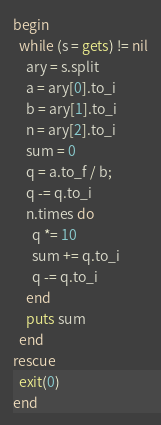Convert code to text. <code><loc_0><loc_0><loc_500><loc_500><_Ruby_>begin
  while (s = gets) != nil
    ary = s.split
    a = ary[0].to_i
    b = ary[1].to_i
    n = ary[2].to_i
    sum = 0
    q = a.to_f / b;
    q -= q.to_i
    n.times do
      q *= 10
      sum += q.to_i
      q -= q.to_i
    end
    puts sum
  end
rescue
  exit(0)
end</code> 